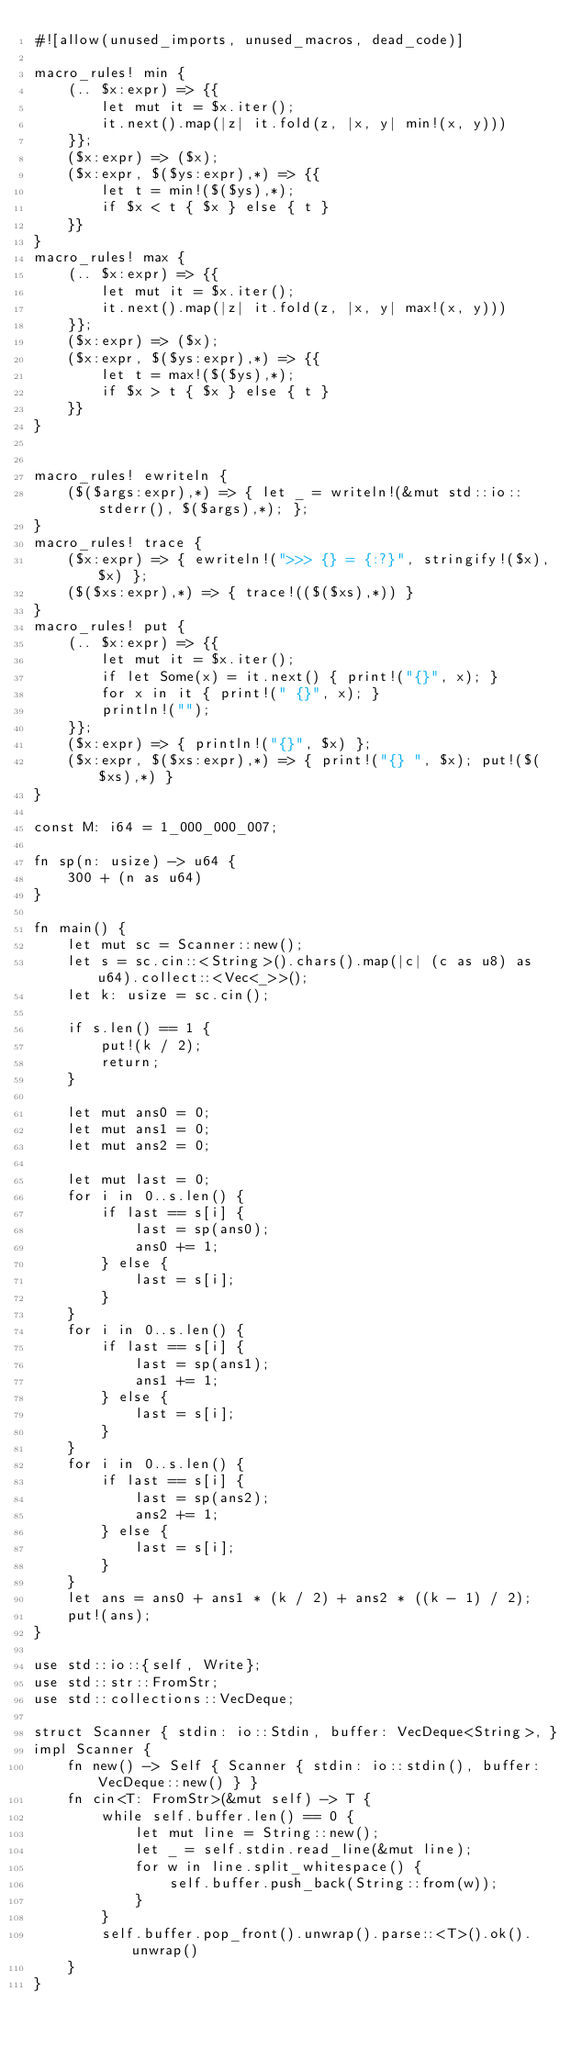Convert code to text. <code><loc_0><loc_0><loc_500><loc_500><_Rust_>#![allow(unused_imports, unused_macros, dead_code)]

macro_rules! min {
    (.. $x:expr) => {{
        let mut it = $x.iter();
        it.next().map(|z| it.fold(z, |x, y| min!(x, y)))
    }};
    ($x:expr) => ($x);
    ($x:expr, $($ys:expr),*) => {{
        let t = min!($($ys),*);
        if $x < t { $x } else { t }
    }}
}
macro_rules! max {
    (.. $x:expr) => {{
        let mut it = $x.iter();
        it.next().map(|z| it.fold(z, |x, y| max!(x, y)))
    }};
    ($x:expr) => ($x);
    ($x:expr, $($ys:expr),*) => {{
        let t = max!($($ys),*);
        if $x > t { $x } else { t }
    }}
}


macro_rules! ewriteln {
    ($($args:expr),*) => { let _ = writeln!(&mut std::io::stderr(), $($args),*); };
}
macro_rules! trace {
    ($x:expr) => { ewriteln!(">>> {} = {:?}", stringify!($x), $x) };
    ($($xs:expr),*) => { trace!(($($xs),*)) }
}
macro_rules! put {
    (.. $x:expr) => {{
        let mut it = $x.iter();
        if let Some(x) = it.next() { print!("{}", x); }
        for x in it { print!(" {}", x); }
        println!("");
    }};
    ($x:expr) => { println!("{}", $x) };
    ($x:expr, $($xs:expr),*) => { print!("{} ", $x); put!($($xs),*) }
}

const M: i64 = 1_000_000_007;

fn sp(n: usize) -> u64 {
    300 + (n as u64)
}

fn main() {
    let mut sc = Scanner::new();
    let s = sc.cin::<String>().chars().map(|c| (c as u8) as u64).collect::<Vec<_>>();
    let k: usize = sc.cin();

    if s.len() == 1 {
        put!(k / 2);
        return;
    }

    let mut ans0 = 0;
    let mut ans1 = 0;
    let mut ans2 = 0;

    let mut last = 0;
    for i in 0..s.len() {
        if last == s[i] {
            last = sp(ans0);
            ans0 += 1;
        } else {
            last = s[i];
        }
    }
    for i in 0..s.len() {
        if last == s[i] {
            last = sp(ans1);
            ans1 += 1;
        } else {
            last = s[i];
        }
    }
    for i in 0..s.len() {
        if last == s[i] {
            last = sp(ans2);
            ans2 += 1;
        } else {
            last = s[i];
        }
    }
    let ans = ans0 + ans1 * (k / 2) + ans2 * ((k - 1) / 2);
    put!(ans);
}

use std::io::{self, Write};
use std::str::FromStr;
use std::collections::VecDeque;

struct Scanner { stdin: io::Stdin, buffer: VecDeque<String>, }
impl Scanner {
    fn new() -> Self { Scanner { stdin: io::stdin(), buffer: VecDeque::new() } }
    fn cin<T: FromStr>(&mut self) -> T {
        while self.buffer.len() == 0 {
            let mut line = String::new();
            let _ = self.stdin.read_line(&mut line);
            for w in line.split_whitespace() {
                self.buffer.push_back(String::from(w));
            }
        }
        self.buffer.pop_front().unwrap().parse::<T>().ok().unwrap()
    }
}
</code> 